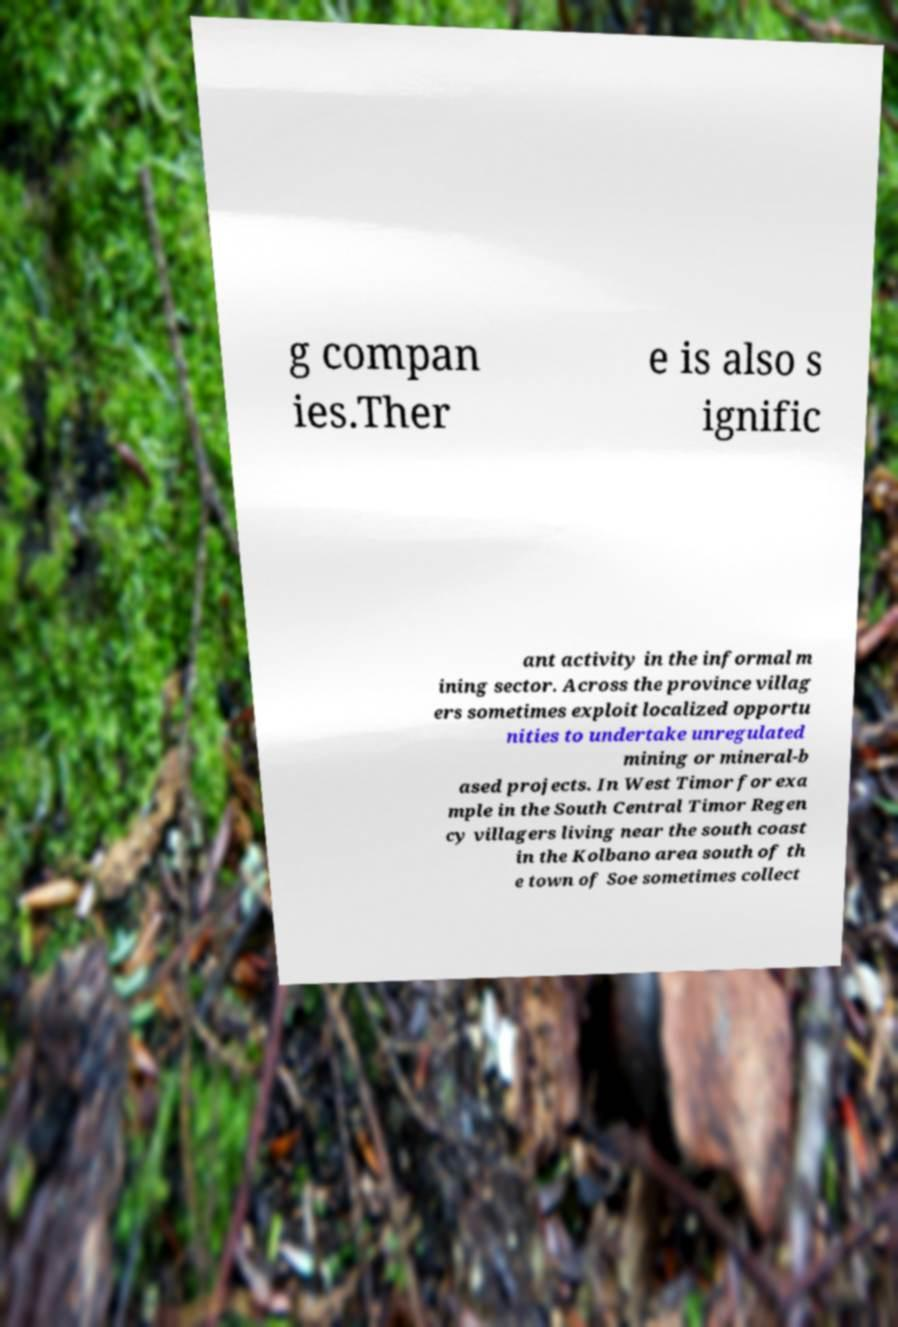What messages or text are displayed in this image? I need them in a readable, typed format. g compan ies.Ther e is also s ignific ant activity in the informal m ining sector. Across the province villag ers sometimes exploit localized opportu nities to undertake unregulated mining or mineral-b ased projects. In West Timor for exa mple in the South Central Timor Regen cy villagers living near the south coast in the Kolbano area south of th e town of Soe sometimes collect 